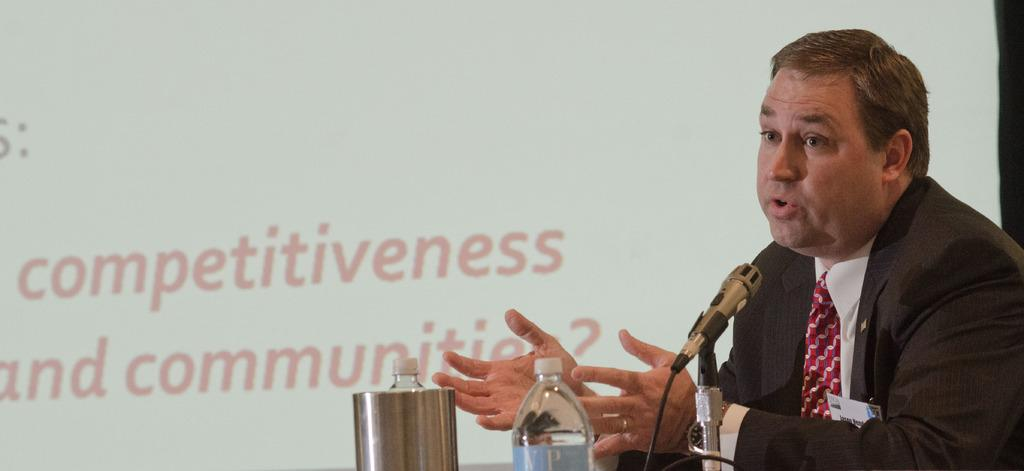Who is present in the image? There is a man in the image. What is the man wearing? The man is wearing a jacket, white shirt, and a tie. What is the man doing in the image? The man is sitting and talking. What object is in front of the man? There is a microphone in front of the man. What items related to hydration can be seen in the image? There is a water bottle and a jug in the image. What can be seen in the background of the image? There is a screen in the background of the image. What type of care does the man express for the balls in the image? There are no balls present in the image, so it is not possible to determine any care expressed by the man. 